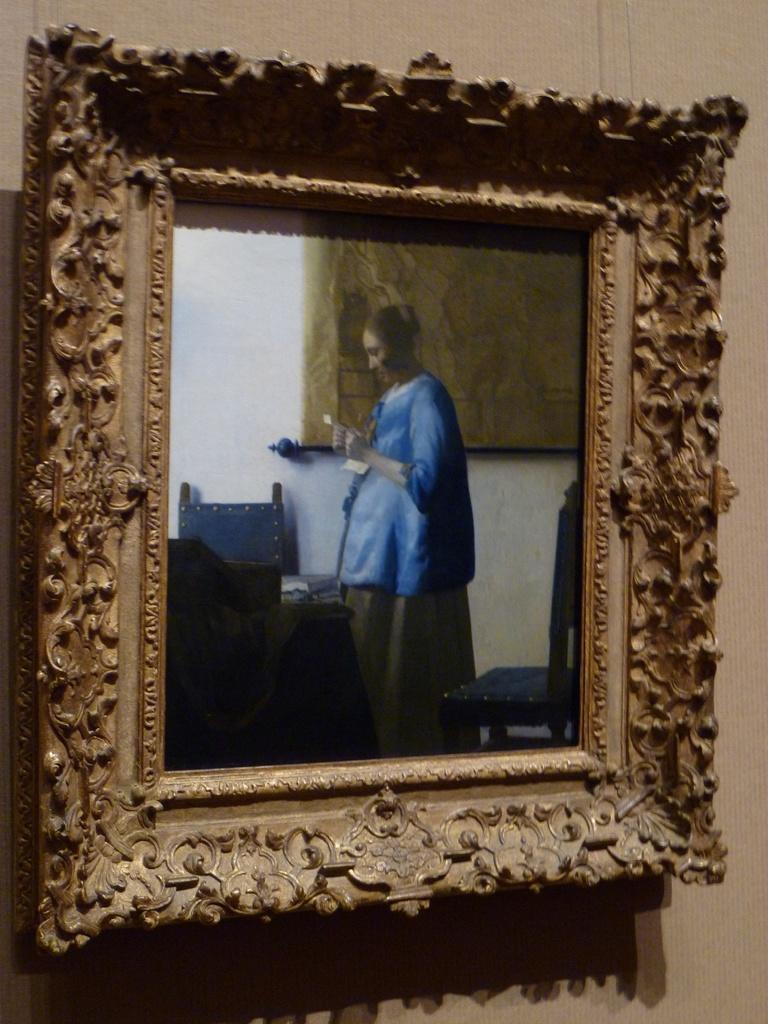Can you describe this image briefly? In this image we can see a photo frame on the wall, in which we can see a woman standing and group of chairs and table placed on the ground. 